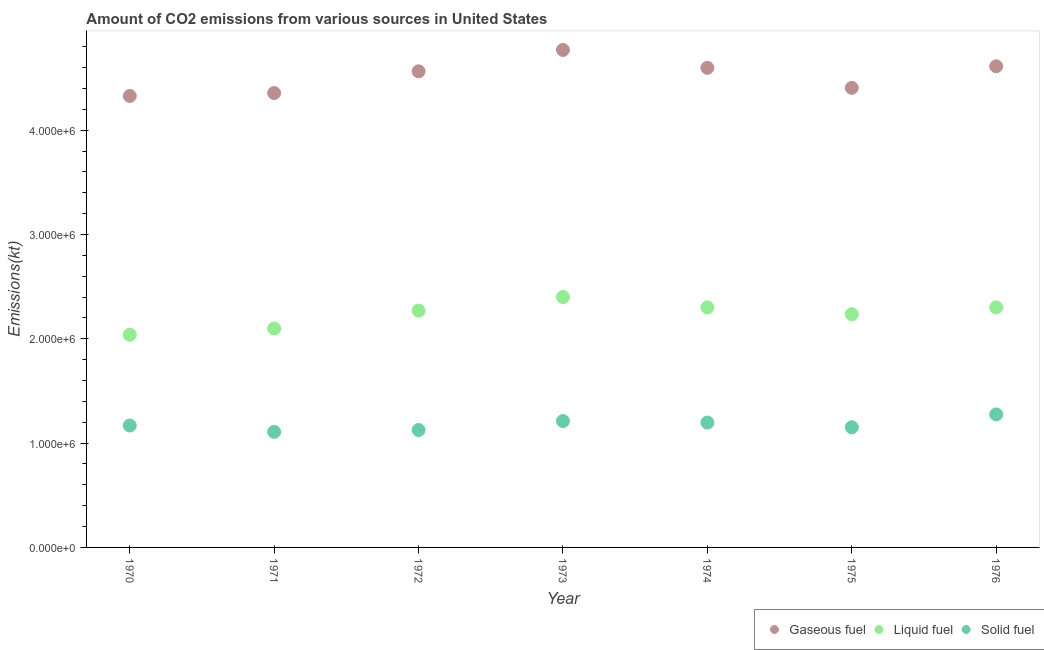Is the number of dotlines equal to the number of legend labels?
Your response must be concise. Yes. What is the amount of co2 emissions from gaseous fuel in 1976?
Provide a succinct answer. 4.61e+06. Across all years, what is the maximum amount of co2 emissions from gaseous fuel?
Provide a short and direct response. 4.77e+06. Across all years, what is the minimum amount of co2 emissions from gaseous fuel?
Offer a very short reply. 4.33e+06. In which year was the amount of co2 emissions from solid fuel maximum?
Provide a short and direct response. 1976. In which year was the amount of co2 emissions from gaseous fuel minimum?
Your answer should be compact. 1970. What is the total amount of co2 emissions from solid fuel in the graph?
Your answer should be very brief. 8.24e+06. What is the difference between the amount of co2 emissions from liquid fuel in 1970 and that in 1976?
Provide a succinct answer. -2.62e+05. What is the difference between the amount of co2 emissions from solid fuel in 1975 and the amount of co2 emissions from liquid fuel in 1970?
Your response must be concise. -8.88e+05. What is the average amount of co2 emissions from gaseous fuel per year?
Offer a terse response. 4.52e+06. In the year 1972, what is the difference between the amount of co2 emissions from liquid fuel and amount of co2 emissions from solid fuel?
Provide a succinct answer. 1.15e+06. In how many years, is the amount of co2 emissions from liquid fuel greater than 2600000 kt?
Give a very brief answer. 0. What is the ratio of the amount of co2 emissions from liquid fuel in 1970 to that in 1975?
Give a very brief answer. 0.91. Is the amount of co2 emissions from liquid fuel in 1973 less than that in 1975?
Ensure brevity in your answer.  No. What is the difference between the highest and the second highest amount of co2 emissions from solid fuel?
Keep it short and to the point. 6.39e+04. What is the difference between the highest and the lowest amount of co2 emissions from liquid fuel?
Your response must be concise. 3.62e+05. In how many years, is the amount of co2 emissions from solid fuel greater than the average amount of co2 emissions from solid fuel taken over all years?
Make the answer very short. 3. Is it the case that in every year, the sum of the amount of co2 emissions from gaseous fuel and amount of co2 emissions from liquid fuel is greater than the amount of co2 emissions from solid fuel?
Provide a succinct answer. Yes. Is the amount of co2 emissions from liquid fuel strictly greater than the amount of co2 emissions from solid fuel over the years?
Provide a short and direct response. Yes. How many dotlines are there?
Give a very brief answer. 3. How many years are there in the graph?
Keep it short and to the point. 7. What is the difference between two consecutive major ticks on the Y-axis?
Make the answer very short. 1.00e+06. Does the graph contain any zero values?
Keep it short and to the point. No. Where does the legend appear in the graph?
Offer a terse response. Bottom right. What is the title of the graph?
Ensure brevity in your answer.  Amount of CO2 emissions from various sources in United States. Does "Primary education" appear as one of the legend labels in the graph?
Your answer should be compact. No. What is the label or title of the X-axis?
Your answer should be very brief. Year. What is the label or title of the Y-axis?
Your answer should be compact. Emissions(kt). What is the Emissions(kt) of Gaseous fuel in 1970?
Offer a terse response. 4.33e+06. What is the Emissions(kt) in Liquid fuel in 1970?
Offer a very short reply. 2.04e+06. What is the Emissions(kt) in Solid fuel in 1970?
Give a very brief answer. 1.17e+06. What is the Emissions(kt) in Gaseous fuel in 1971?
Your answer should be very brief. 4.36e+06. What is the Emissions(kt) in Liquid fuel in 1971?
Your response must be concise. 2.10e+06. What is the Emissions(kt) of Solid fuel in 1971?
Offer a terse response. 1.11e+06. What is the Emissions(kt) of Gaseous fuel in 1972?
Provide a succinct answer. 4.56e+06. What is the Emissions(kt) in Liquid fuel in 1972?
Give a very brief answer. 2.27e+06. What is the Emissions(kt) in Solid fuel in 1972?
Give a very brief answer. 1.13e+06. What is the Emissions(kt) in Gaseous fuel in 1973?
Offer a very short reply. 4.77e+06. What is the Emissions(kt) in Liquid fuel in 1973?
Make the answer very short. 2.40e+06. What is the Emissions(kt) in Solid fuel in 1973?
Your response must be concise. 1.21e+06. What is the Emissions(kt) of Gaseous fuel in 1974?
Give a very brief answer. 4.60e+06. What is the Emissions(kt) of Liquid fuel in 1974?
Keep it short and to the point. 2.30e+06. What is the Emissions(kt) in Solid fuel in 1974?
Your response must be concise. 1.20e+06. What is the Emissions(kt) of Gaseous fuel in 1975?
Your answer should be very brief. 4.41e+06. What is the Emissions(kt) of Liquid fuel in 1975?
Your response must be concise. 2.24e+06. What is the Emissions(kt) in Solid fuel in 1975?
Make the answer very short. 1.15e+06. What is the Emissions(kt) in Gaseous fuel in 1976?
Keep it short and to the point. 4.61e+06. What is the Emissions(kt) of Liquid fuel in 1976?
Offer a terse response. 2.30e+06. What is the Emissions(kt) of Solid fuel in 1976?
Give a very brief answer. 1.28e+06. Across all years, what is the maximum Emissions(kt) in Gaseous fuel?
Provide a short and direct response. 4.77e+06. Across all years, what is the maximum Emissions(kt) in Liquid fuel?
Give a very brief answer. 2.40e+06. Across all years, what is the maximum Emissions(kt) of Solid fuel?
Give a very brief answer. 1.28e+06. Across all years, what is the minimum Emissions(kt) of Gaseous fuel?
Provide a succinct answer. 4.33e+06. Across all years, what is the minimum Emissions(kt) of Liquid fuel?
Your response must be concise. 2.04e+06. Across all years, what is the minimum Emissions(kt) in Solid fuel?
Ensure brevity in your answer.  1.11e+06. What is the total Emissions(kt) of Gaseous fuel in the graph?
Offer a terse response. 3.16e+07. What is the total Emissions(kt) of Liquid fuel in the graph?
Offer a terse response. 1.57e+07. What is the total Emissions(kt) of Solid fuel in the graph?
Keep it short and to the point. 8.24e+06. What is the difference between the Emissions(kt) of Gaseous fuel in 1970 and that in 1971?
Make the answer very short. -2.79e+04. What is the difference between the Emissions(kt) in Liquid fuel in 1970 and that in 1971?
Your response must be concise. -5.93e+04. What is the difference between the Emissions(kt) of Solid fuel in 1970 and that in 1971?
Provide a succinct answer. 6.07e+04. What is the difference between the Emissions(kt) of Gaseous fuel in 1970 and that in 1972?
Provide a short and direct response. -2.36e+05. What is the difference between the Emissions(kt) of Liquid fuel in 1970 and that in 1972?
Ensure brevity in your answer.  -2.31e+05. What is the difference between the Emissions(kt) in Solid fuel in 1970 and that in 1972?
Ensure brevity in your answer.  4.33e+04. What is the difference between the Emissions(kt) in Gaseous fuel in 1970 and that in 1973?
Your response must be concise. -4.41e+05. What is the difference between the Emissions(kt) of Liquid fuel in 1970 and that in 1973?
Your response must be concise. -3.62e+05. What is the difference between the Emissions(kt) in Solid fuel in 1970 and that in 1973?
Offer a very short reply. -4.25e+04. What is the difference between the Emissions(kt) of Gaseous fuel in 1970 and that in 1974?
Give a very brief answer. -2.70e+05. What is the difference between the Emissions(kt) in Liquid fuel in 1970 and that in 1974?
Offer a very short reply. -2.62e+05. What is the difference between the Emissions(kt) of Solid fuel in 1970 and that in 1974?
Ensure brevity in your answer.  -2.82e+04. What is the difference between the Emissions(kt) in Gaseous fuel in 1970 and that in 1975?
Your answer should be compact. -7.74e+04. What is the difference between the Emissions(kt) in Liquid fuel in 1970 and that in 1975?
Your answer should be very brief. -1.97e+05. What is the difference between the Emissions(kt) of Solid fuel in 1970 and that in 1975?
Keep it short and to the point. 1.69e+04. What is the difference between the Emissions(kt) of Gaseous fuel in 1970 and that in 1976?
Your response must be concise. -2.84e+05. What is the difference between the Emissions(kt) of Liquid fuel in 1970 and that in 1976?
Your response must be concise. -2.62e+05. What is the difference between the Emissions(kt) in Solid fuel in 1970 and that in 1976?
Give a very brief answer. -1.06e+05. What is the difference between the Emissions(kt) of Gaseous fuel in 1971 and that in 1972?
Offer a very short reply. -2.08e+05. What is the difference between the Emissions(kt) of Liquid fuel in 1971 and that in 1972?
Your answer should be very brief. -1.72e+05. What is the difference between the Emissions(kt) in Solid fuel in 1971 and that in 1972?
Ensure brevity in your answer.  -1.74e+04. What is the difference between the Emissions(kt) of Gaseous fuel in 1971 and that in 1973?
Provide a succinct answer. -4.13e+05. What is the difference between the Emissions(kt) of Liquid fuel in 1971 and that in 1973?
Offer a very short reply. -3.02e+05. What is the difference between the Emissions(kt) of Solid fuel in 1971 and that in 1973?
Provide a succinct answer. -1.03e+05. What is the difference between the Emissions(kt) in Gaseous fuel in 1971 and that in 1974?
Your answer should be very brief. -2.42e+05. What is the difference between the Emissions(kt) of Liquid fuel in 1971 and that in 1974?
Ensure brevity in your answer.  -2.03e+05. What is the difference between the Emissions(kt) in Solid fuel in 1971 and that in 1974?
Keep it short and to the point. -8.89e+04. What is the difference between the Emissions(kt) in Gaseous fuel in 1971 and that in 1975?
Ensure brevity in your answer.  -4.96e+04. What is the difference between the Emissions(kt) of Liquid fuel in 1971 and that in 1975?
Make the answer very short. -1.38e+05. What is the difference between the Emissions(kt) of Solid fuel in 1971 and that in 1975?
Your answer should be very brief. -4.39e+04. What is the difference between the Emissions(kt) of Gaseous fuel in 1971 and that in 1976?
Offer a very short reply. -2.56e+05. What is the difference between the Emissions(kt) in Liquid fuel in 1971 and that in 1976?
Your answer should be very brief. -2.02e+05. What is the difference between the Emissions(kt) in Solid fuel in 1971 and that in 1976?
Make the answer very short. -1.67e+05. What is the difference between the Emissions(kt) of Gaseous fuel in 1972 and that in 1973?
Keep it short and to the point. -2.05e+05. What is the difference between the Emissions(kt) of Liquid fuel in 1972 and that in 1973?
Provide a short and direct response. -1.30e+05. What is the difference between the Emissions(kt) in Solid fuel in 1972 and that in 1973?
Provide a succinct answer. -8.58e+04. What is the difference between the Emissions(kt) in Gaseous fuel in 1972 and that in 1974?
Provide a succinct answer. -3.35e+04. What is the difference between the Emissions(kt) in Liquid fuel in 1972 and that in 1974?
Keep it short and to the point. -3.08e+04. What is the difference between the Emissions(kt) in Solid fuel in 1972 and that in 1974?
Offer a very short reply. -7.15e+04. What is the difference between the Emissions(kt) in Gaseous fuel in 1972 and that in 1975?
Provide a succinct answer. 1.59e+05. What is the difference between the Emissions(kt) of Liquid fuel in 1972 and that in 1975?
Give a very brief answer. 3.45e+04. What is the difference between the Emissions(kt) of Solid fuel in 1972 and that in 1975?
Your answer should be very brief. -2.64e+04. What is the difference between the Emissions(kt) in Gaseous fuel in 1972 and that in 1976?
Ensure brevity in your answer.  -4.81e+04. What is the difference between the Emissions(kt) in Liquid fuel in 1972 and that in 1976?
Ensure brevity in your answer.  -3.03e+04. What is the difference between the Emissions(kt) of Solid fuel in 1972 and that in 1976?
Offer a terse response. -1.50e+05. What is the difference between the Emissions(kt) of Gaseous fuel in 1973 and that in 1974?
Provide a short and direct response. 1.72e+05. What is the difference between the Emissions(kt) of Liquid fuel in 1973 and that in 1974?
Your response must be concise. 9.97e+04. What is the difference between the Emissions(kt) of Solid fuel in 1973 and that in 1974?
Ensure brevity in your answer.  1.43e+04. What is the difference between the Emissions(kt) in Gaseous fuel in 1973 and that in 1975?
Provide a short and direct response. 3.64e+05. What is the difference between the Emissions(kt) in Liquid fuel in 1973 and that in 1975?
Provide a short and direct response. 1.65e+05. What is the difference between the Emissions(kt) in Solid fuel in 1973 and that in 1975?
Provide a succinct answer. 5.94e+04. What is the difference between the Emissions(kt) in Gaseous fuel in 1973 and that in 1976?
Your answer should be compact. 1.57e+05. What is the difference between the Emissions(kt) in Liquid fuel in 1973 and that in 1976?
Your answer should be very brief. 1.00e+05. What is the difference between the Emissions(kt) of Solid fuel in 1973 and that in 1976?
Ensure brevity in your answer.  -6.39e+04. What is the difference between the Emissions(kt) in Gaseous fuel in 1974 and that in 1975?
Your answer should be compact. 1.92e+05. What is the difference between the Emissions(kt) of Liquid fuel in 1974 and that in 1975?
Your response must be concise. 6.52e+04. What is the difference between the Emissions(kt) in Solid fuel in 1974 and that in 1975?
Offer a terse response. 4.51e+04. What is the difference between the Emissions(kt) in Gaseous fuel in 1974 and that in 1976?
Your answer should be compact. -1.46e+04. What is the difference between the Emissions(kt) in Liquid fuel in 1974 and that in 1976?
Provide a short and direct response. 476.71. What is the difference between the Emissions(kt) of Solid fuel in 1974 and that in 1976?
Offer a terse response. -7.82e+04. What is the difference between the Emissions(kt) in Gaseous fuel in 1975 and that in 1976?
Your answer should be compact. -2.07e+05. What is the difference between the Emissions(kt) in Liquid fuel in 1975 and that in 1976?
Provide a succinct answer. -6.47e+04. What is the difference between the Emissions(kt) of Solid fuel in 1975 and that in 1976?
Your response must be concise. -1.23e+05. What is the difference between the Emissions(kt) in Gaseous fuel in 1970 and the Emissions(kt) in Liquid fuel in 1971?
Offer a terse response. 2.23e+06. What is the difference between the Emissions(kt) of Gaseous fuel in 1970 and the Emissions(kt) of Solid fuel in 1971?
Your answer should be compact. 3.22e+06. What is the difference between the Emissions(kt) in Liquid fuel in 1970 and the Emissions(kt) in Solid fuel in 1971?
Your response must be concise. 9.31e+05. What is the difference between the Emissions(kt) of Gaseous fuel in 1970 and the Emissions(kt) of Liquid fuel in 1972?
Offer a very short reply. 2.06e+06. What is the difference between the Emissions(kt) of Gaseous fuel in 1970 and the Emissions(kt) of Solid fuel in 1972?
Make the answer very short. 3.20e+06. What is the difference between the Emissions(kt) of Liquid fuel in 1970 and the Emissions(kt) of Solid fuel in 1972?
Ensure brevity in your answer.  9.14e+05. What is the difference between the Emissions(kt) in Gaseous fuel in 1970 and the Emissions(kt) in Liquid fuel in 1973?
Make the answer very short. 1.93e+06. What is the difference between the Emissions(kt) in Gaseous fuel in 1970 and the Emissions(kt) in Solid fuel in 1973?
Provide a short and direct response. 3.12e+06. What is the difference between the Emissions(kt) of Liquid fuel in 1970 and the Emissions(kt) of Solid fuel in 1973?
Keep it short and to the point. 8.28e+05. What is the difference between the Emissions(kt) of Gaseous fuel in 1970 and the Emissions(kt) of Liquid fuel in 1974?
Your response must be concise. 2.03e+06. What is the difference between the Emissions(kt) in Gaseous fuel in 1970 and the Emissions(kt) in Solid fuel in 1974?
Offer a terse response. 3.13e+06. What is the difference between the Emissions(kt) of Liquid fuel in 1970 and the Emissions(kt) of Solid fuel in 1974?
Give a very brief answer. 8.42e+05. What is the difference between the Emissions(kt) of Gaseous fuel in 1970 and the Emissions(kt) of Liquid fuel in 1975?
Keep it short and to the point. 2.09e+06. What is the difference between the Emissions(kt) of Gaseous fuel in 1970 and the Emissions(kt) of Solid fuel in 1975?
Keep it short and to the point. 3.18e+06. What is the difference between the Emissions(kt) in Liquid fuel in 1970 and the Emissions(kt) in Solid fuel in 1975?
Make the answer very short. 8.88e+05. What is the difference between the Emissions(kt) in Gaseous fuel in 1970 and the Emissions(kt) in Liquid fuel in 1976?
Provide a short and direct response. 2.03e+06. What is the difference between the Emissions(kt) of Gaseous fuel in 1970 and the Emissions(kt) of Solid fuel in 1976?
Provide a short and direct response. 3.05e+06. What is the difference between the Emissions(kt) of Liquid fuel in 1970 and the Emissions(kt) of Solid fuel in 1976?
Your answer should be very brief. 7.64e+05. What is the difference between the Emissions(kt) of Gaseous fuel in 1971 and the Emissions(kt) of Liquid fuel in 1972?
Your response must be concise. 2.09e+06. What is the difference between the Emissions(kt) of Gaseous fuel in 1971 and the Emissions(kt) of Solid fuel in 1972?
Your response must be concise. 3.23e+06. What is the difference between the Emissions(kt) of Liquid fuel in 1971 and the Emissions(kt) of Solid fuel in 1972?
Keep it short and to the point. 9.73e+05. What is the difference between the Emissions(kt) of Gaseous fuel in 1971 and the Emissions(kt) of Liquid fuel in 1973?
Your response must be concise. 1.96e+06. What is the difference between the Emissions(kt) of Gaseous fuel in 1971 and the Emissions(kt) of Solid fuel in 1973?
Your answer should be very brief. 3.15e+06. What is the difference between the Emissions(kt) in Liquid fuel in 1971 and the Emissions(kt) in Solid fuel in 1973?
Your answer should be compact. 8.87e+05. What is the difference between the Emissions(kt) in Gaseous fuel in 1971 and the Emissions(kt) in Liquid fuel in 1974?
Provide a succinct answer. 2.05e+06. What is the difference between the Emissions(kt) in Gaseous fuel in 1971 and the Emissions(kt) in Solid fuel in 1974?
Offer a very short reply. 3.16e+06. What is the difference between the Emissions(kt) in Liquid fuel in 1971 and the Emissions(kt) in Solid fuel in 1974?
Your answer should be very brief. 9.02e+05. What is the difference between the Emissions(kt) of Gaseous fuel in 1971 and the Emissions(kt) of Liquid fuel in 1975?
Your answer should be compact. 2.12e+06. What is the difference between the Emissions(kt) in Gaseous fuel in 1971 and the Emissions(kt) in Solid fuel in 1975?
Make the answer very short. 3.20e+06. What is the difference between the Emissions(kt) in Liquid fuel in 1971 and the Emissions(kt) in Solid fuel in 1975?
Your answer should be compact. 9.47e+05. What is the difference between the Emissions(kt) of Gaseous fuel in 1971 and the Emissions(kt) of Liquid fuel in 1976?
Provide a succinct answer. 2.06e+06. What is the difference between the Emissions(kt) of Gaseous fuel in 1971 and the Emissions(kt) of Solid fuel in 1976?
Keep it short and to the point. 3.08e+06. What is the difference between the Emissions(kt) of Liquid fuel in 1971 and the Emissions(kt) of Solid fuel in 1976?
Your answer should be very brief. 8.24e+05. What is the difference between the Emissions(kt) in Gaseous fuel in 1972 and the Emissions(kt) in Liquid fuel in 1973?
Your answer should be very brief. 2.16e+06. What is the difference between the Emissions(kt) of Gaseous fuel in 1972 and the Emissions(kt) of Solid fuel in 1973?
Offer a very short reply. 3.35e+06. What is the difference between the Emissions(kt) in Liquid fuel in 1972 and the Emissions(kt) in Solid fuel in 1973?
Ensure brevity in your answer.  1.06e+06. What is the difference between the Emissions(kt) of Gaseous fuel in 1972 and the Emissions(kt) of Liquid fuel in 1974?
Your answer should be compact. 2.26e+06. What is the difference between the Emissions(kt) of Gaseous fuel in 1972 and the Emissions(kt) of Solid fuel in 1974?
Your answer should be compact. 3.37e+06. What is the difference between the Emissions(kt) of Liquid fuel in 1972 and the Emissions(kt) of Solid fuel in 1974?
Give a very brief answer. 1.07e+06. What is the difference between the Emissions(kt) of Gaseous fuel in 1972 and the Emissions(kt) of Liquid fuel in 1975?
Give a very brief answer. 2.33e+06. What is the difference between the Emissions(kt) in Gaseous fuel in 1972 and the Emissions(kt) in Solid fuel in 1975?
Keep it short and to the point. 3.41e+06. What is the difference between the Emissions(kt) of Liquid fuel in 1972 and the Emissions(kt) of Solid fuel in 1975?
Your answer should be very brief. 1.12e+06. What is the difference between the Emissions(kt) in Gaseous fuel in 1972 and the Emissions(kt) in Liquid fuel in 1976?
Give a very brief answer. 2.26e+06. What is the difference between the Emissions(kt) of Gaseous fuel in 1972 and the Emissions(kt) of Solid fuel in 1976?
Your answer should be very brief. 3.29e+06. What is the difference between the Emissions(kt) of Liquid fuel in 1972 and the Emissions(kt) of Solid fuel in 1976?
Your response must be concise. 9.96e+05. What is the difference between the Emissions(kt) in Gaseous fuel in 1973 and the Emissions(kt) in Liquid fuel in 1974?
Offer a very short reply. 2.47e+06. What is the difference between the Emissions(kt) of Gaseous fuel in 1973 and the Emissions(kt) of Solid fuel in 1974?
Your response must be concise. 3.57e+06. What is the difference between the Emissions(kt) of Liquid fuel in 1973 and the Emissions(kt) of Solid fuel in 1974?
Give a very brief answer. 1.20e+06. What is the difference between the Emissions(kt) in Gaseous fuel in 1973 and the Emissions(kt) in Liquid fuel in 1975?
Your response must be concise. 2.53e+06. What is the difference between the Emissions(kt) in Gaseous fuel in 1973 and the Emissions(kt) in Solid fuel in 1975?
Give a very brief answer. 3.62e+06. What is the difference between the Emissions(kt) in Liquid fuel in 1973 and the Emissions(kt) in Solid fuel in 1975?
Give a very brief answer. 1.25e+06. What is the difference between the Emissions(kt) of Gaseous fuel in 1973 and the Emissions(kt) of Liquid fuel in 1976?
Your response must be concise. 2.47e+06. What is the difference between the Emissions(kt) in Gaseous fuel in 1973 and the Emissions(kt) in Solid fuel in 1976?
Offer a very short reply. 3.49e+06. What is the difference between the Emissions(kt) in Liquid fuel in 1973 and the Emissions(kt) in Solid fuel in 1976?
Offer a very short reply. 1.13e+06. What is the difference between the Emissions(kt) of Gaseous fuel in 1974 and the Emissions(kt) of Liquid fuel in 1975?
Offer a very short reply. 2.36e+06. What is the difference between the Emissions(kt) in Gaseous fuel in 1974 and the Emissions(kt) in Solid fuel in 1975?
Your answer should be compact. 3.45e+06. What is the difference between the Emissions(kt) in Liquid fuel in 1974 and the Emissions(kt) in Solid fuel in 1975?
Make the answer very short. 1.15e+06. What is the difference between the Emissions(kt) of Gaseous fuel in 1974 and the Emissions(kt) of Liquid fuel in 1976?
Your answer should be very brief. 2.30e+06. What is the difference between the Emissions(kt) of Gaseous fuel in 1974 and the Emissions(kt) of Solid fuel in 1976?
Give a very brief answer. 3.32e+06. What is the difference between the Emissions(kt) in Liquid fuel in 1974 and the Emissions(kt) in Solid fuel in 1976?
Your answer should be very brief. 1.03e+06. What is the difference between the Emissions(kt) of Gaseous fuel in 1975 and the Emissions(kt) of Liquid fuel in 1976?
Provide a succinct answer. 2.11e+06. What is the difference between the Emissions(kt) in Gaseous fuel in 1975 and the Emissions(kt) in Solid fuel in 1976?
Ensure brevity in your answer.  3.13e+06. What is the difference between the Emissions(kt) of Liquid fuel in 1975 and the Emissions(kt) of Solid fuel in 1976?
Provide a short and direct response. 9.61e+05. What is the average Emissions(kt) in Gaseous fuel per year?
Offer a very short reply. 4.52e+06. What is the average Emissions(kt) in Liquid fuel per year?
Your answer should be compact. 2.24e+06. What is the average Emissions(kt) in Solid fuel per year?
Give a very brief answer. 1.18e+06. In the year 1970, what is the difference between the Emissions(kt) in Gaseous fuel and Emissions(kt) in Liquid fuel?
Your response must be concise. 2.29e+06. In the year 1970, what is the difference between the Emissions(kt) of Gaseous fuel and Emissions(kt) of Solid fuel?
Give a very brief answer. 3.16e+06. In the year 1970, what is the difference between the Emissions(kt) in Liquid fuel and Emissions(kt) in Solid fuel?
Offer a terse response. 8.71e+05. In the year 1971, what is the difference between the Emissions(kt) in Gaseous fuel and Emissions(kt) in Liquid fuel?
Offer a terse response. 2.26e+06. In the year 1971, what is the difference between the Emissions(kt) in Gaseous fuel and Emissions(kt) in Solid fuel?
Your answer should be compact. 3.25e+06. In the year 1971, what is the difference between the Emissions(kt) of Liquid fuel and Emissions(kt) of Solid fuel?
Make the answer very short. 9.91e+05. In the year 1972, what is the difference between the Emissions(kt) in Gaseous fuel and Emissions(kt) in Liquid fuel?
Your answer should be very brief. 2.29e+06. In the year 1972, what is the difference between the Emissions(kt) in Gaseous fuel and Emissions(kt) in Solid fuel?
Give a very brief answer. 3.44e+06. In the year 1972, what is the difference between the Emissions(kt) of Liquid fuel and Emissions(kt) of Solid fuel?
Make the answer very short. 1.15e+06. In the year 1973, what is the difference between the Emissions(kt) of Gaseous fuel and Emissions(kt) of Liquid fuel?
Provide a short and direct response. 2.37e+06. In the year 1973, what is the difference between the Emissions(kt) of Gaseous fuel and Emissions(kt) of Solid fuel?
Keep it short and to the point. 3.56e+06. In the year 1973, what is the difference between the Emissions(kt) of Liquid fuel and Emissions(kt) of Solid fuel?
Keep it short and to the point. 1.19e+06. In the year 1974, what is the difference between the Emissions(kt) in Gaseous fuel and Emissions(kt) in Liquid fuel?
Give a very brief answer. 2.30e+06. In the year 1974, what is the difference between the Emissions(kt) in Gaseous fuel and Emissions(kt) in Solid fuel?
Ensure brevity in your answer.  3.40e+06. In the year 1974, what is the difference between the Emissions(kt) of Liquid fuel and Emissions(kt) of Solid fuel?
Your response must be concise. 1.10e+06. In the year 1975, what is the difference between the Emissions(kt) of Gaseous fuel and Emissions(kt) of Liquid fuel?
Ensure brevity in your answer.  2.17e+06. In the year 1975, what is the difference between the Emissions(kt) in Gaseous fuel and Emissions(kt) in Solid fuel?
Your response must be concise. 3.25e+06. In the year 1975, what is the difference between the Emissions(kt) in Liquid fuel and Emissions(kt) in Solid fuel?
Keep it short and to the point. 1.08e+06. In the year 1976, what is the difference between the Emissions(kt) of Gaseous fuel and Emissions(kt) of Liquid fuel?
Make the answer very short. 2.31e+06. In the year 1976, what is the difference between the Emissions(kt) of Gaseous fuel and Emissions(kt) of Solid fuel?
Keep it short and to the point. 3.34e+06. In the year 1976, what is the difference between the Emissions(kt) of Liquid fuel and Emissions(kt) of Solid fuel?
Your answer should be very brief. 1.03e+06. What is the ratio of the Emissions(kt) in Gaseous fuel in 1970 to that in 1971?
Keep it short and to the point. 0.99. What is the ratio of the Emissions(kt) in Liquid fuel in 1970 to that in 1971?
Provide a short and direct response. 0.97. What is the ratio of the Emissions(kt) of Solid fuel in 1970 to that in 1971?
Give a very brief answer. 1.05. What is the ratio of the Emissions(kt) in Gaseous fuel in 1970 to that in 1972?
Offer a very short reply. 0.95. What is the ratio of the Emissions(kt) in Liquid fuel in 1970 to that in 1972?
Provide a short and direct response. 0.9. What is the ratio of the Emissions(kt) in Solid fuel in 1970 to that in 1972?
Offer a terse response. 1.04. What is the ratio of the Emissions(kt) of Gaseous fuel in 1970 to that in 1973?
Make the answer very short. 0.91. What is the ratio of the Emissions(kt) in Liquid fuel in 1970 to that in 1973?
Ensure brevity in your answer.  0.85. What is the ratio of the Emissions(kt) of Solid fuel in 1970 to that in 1973?
Give a very brief answer. 0.96. What is the ratio of the Emissions(kt) in Gaseous fuel in 1970 to that in 1974?
Ensure brevity in your answer.  0.94. What is the ratio of the Emissions(kt) in Liquid fuel in 1970 to that in 1974?
Your answer should be compact. 0.89. What is the ratio of the Emissions(kt) in Solid fuel in 1970 to that in 1974?
Your response must be concise. 0.98. What is the ratio of the Emissions(kt) of Gaseous fuel in 1970 to that in 1975?
Your response must be concise. 0.98. What is the ratio of the Emissions(kt) in Liquid fuel in 1970 to that in 1975?
Offer a very short reply. 0.91. What is the ratio of the Emissions(kt) of Solid fuel in 1970 to that in 1975?
Offer a terse response. 1.01. What is the ratio of the Emissions(kt) of Gaseous fuel in 1970 to that in 1976?
Ensure brevity in your answer.  0.94. What is the ratio of the Emissions(kt) in Liquid fuel in 1970 to that in 1976?
Your answer should be very brief. 0.89. What is the ratio of the Emissions(kt) in Solid fuel in 1970 to that in 1976?
Provide a succinct answer. 0.92. What is the ratio of the Emissions(kt) of Gaseous fuel in 1971 to that in 1972?
Ensure brevity in your answer.  0.95. What is the ratio of the Emissions(kt) of Liquid fuel in 1971 to that in 1972?
Provide a succinct answer. 0.92. What is the ratio of the Emissions(kt) of Solid fuel in 1971 to that in 1972?
Keep it short and to the point. 0.98. What is the ratio of the Emissions(kt) of Gaseous fuel in 1971 to that in 1973?
Ensure brevity in your answer.  0.91. What is the ratio of the Emissions(kt) in Liquid fuel in 1971 to that in 1973?
Offer a very short reply. 0.87. What is the ratio of the Emissions(kt) in Solid fuel in 1971 to that in 1973?
Keep it short and to the point. 0.91. What is the ratio of the Emissions(kt) of Gaseous fuel in 1971 to that in 1974?
Provide a succinct answer. 0.95. What is the ratio of the Emissions(kt) in Liquid fuel in 1971 to that in 1974?
Offer a terse response. 0.91. What is the ratio of the Emissions(kt) in Solid fuel in 1971 to that in 1974?
Provide a succinct answer. 0.93. What is the ratio of the Emissions(kt) of Gaseous fuel in 1971 to that in 1975?
Keep it short and to the point. 0.99. What is the ratio of the Emissions(kt) in Liquid fuel in 1971 to that in 1975?
Your answer should be compact. 0.94. What is the ratio of the Emissions(kt) in Solid fuel in 1971 to that in 1975?
Keep it short and to the point. 0.96. What is the ratio of the Emissions(kt) in Gaseous fuel in 1971 to that in 1976?
Your response must be concise. 0.94. What is the ratio of the Emissions(kt) in Liquid fuel in 1971 to that in 1976?
Your answer should be compact. 0.91. What is the ratio of the Emissions(kt) of Solid fuel in 1971 to that in 1976?
Your answer should be compact. 0.87. What is the ratio of the Emissions(kt) in Gaseous fuel in 1972 to that in 1973?
Offer a very short reply. 0.96. What is the ratio of the Emissions(kt) in Liquid fuel in 1972 to that in 1973?
Give a very brief answer. 0.95. What is the ratio of the Emissions(kt) in Solid fuel in 1972 to that in 1973?
Ensure brevity in your answer.  0.93. What is the ratio of the Emissions(kt) in Liquid fuel in 1972 to that in 1974?
Your answer should be compact. 0.99. What is the ratio of the Emissions(kt) in Solid fuel in 1972 to that in 1974?
Keep it short and to the point. 0.94. What is the ratio of the Emissions(kt) of Gaseous fuel in 1972 to that in 1975?
Provide a succinct answer. 1.04. What is the ratio of the Emissions(kt) in Liquid fuel in 1972 to that in 1975?
Give a very brief answer. 1.02. What is the ratio of the Emissions(kt) in Solid fuel in 1972 to that in 1975?
Make the answer very short. 0.98. What is the ratio of the Emissions(kt) of Solid fuel in 1972 to that in 1976?
Your answer should be compact. 0.88. What is the ratio of the Emissions(kt) in Gaseous fuel in 1973 to that in 1974?
Provide a short and direct response. 1.04. What is the ratio of the Emissions(kt) in Liquid fuel in 1973 to that in 1974?
Make the answer very short. 1.04. What is the ratio of the Emissions(kt) in Solid fuel in 1973 to that in 1974?
Provide a short and direct response. 1.01. What is the ratio of the Emissions(kt) of Gaseous fuel in 1973 to that in 1975?
Your answer should be very brief. 1.08. What is the ratio of the Emissions(kt) of Liquid fuel in 1973 to that in 1975?
Give a very brief answer. 1.07. What is the ratio of the Emissions(kt) of Solid fuel in 1973 to that in 1975?
Ensure brevity in your answer.  1.05. What is the ratio of the Emissions(kt) in Gaseous fuel in 1973 to that in 1976?
Give a very brief answer. 1.03. What is the ratio of the Emissions(kt) in Liquid fuel in 1973 to that in 1976?
Give a very brief answer. 1.04. What is the ratio of the Emissions(kt) of Solid fuel in 1973 to that in 1976?
Offer a very short reply. 0.95. What is the ratio of the Emissions(kt) of Gaseous fuel in 1974 to that in 1975?
Make the answer very short. 1.04. What is the ratio of the Emissions(kt) of Liquid fuel in 1974 to that in 1975?
Your answer should be compact. 1.03. What is the ratio of the Emissions(kt) in Solid fuel in 1974 to that in 1975?
Provide a short and direct response. 1.04. What is the ratio of the Emissions(kt) in Gaseous fuel in 1974 to that in 1976?
Ensure brevity in your answer.  1. What is the ratio of the Emissions(kt) of Solid fuel in 1974 to that in 1976?
Make the answer very short. 0.94. What is the ratio of the Emissions(kt) in Gaseous fuel in 1975 to that in 1976?
Keep it short and to the point. 0.96. What is the ratio of the Emissions(kt) of Liquid fuel in 1975 to that in 1976?
Keep it short and to the point. 0.97. What is the ratio of the Emissions(kt) in Solid fuel in 1975 to that in 1976?
Provide a succinct answer. 0.9. What is the difference between the highest and the second highest Emissions(kt) of Gaseous fuel?
Offer a terse response. 1.57e+05. What is the difference between the highest and the second highest Emissions(kt) in Liquid fuel?
Offer a terse response. 9.97e+04. What is the difference between the highest and the second highest Emissions(kt) in Solid fuel?
Give a very brief answer. 6.39e+04. What is the difference between the highest and the lowest Emissions(kt) of Gaseous fuel?
Offer a very short reply. 4.41e+05. What is the difference between the highest and the lowest Emissions(kt) in Liquid fuel?
Provide a succinct answer. 3.62e+05. What is the difference between the highest and the lowest Emissions(kt) of Solid fuel?
Your answer should be compact. 1.67e+05. 